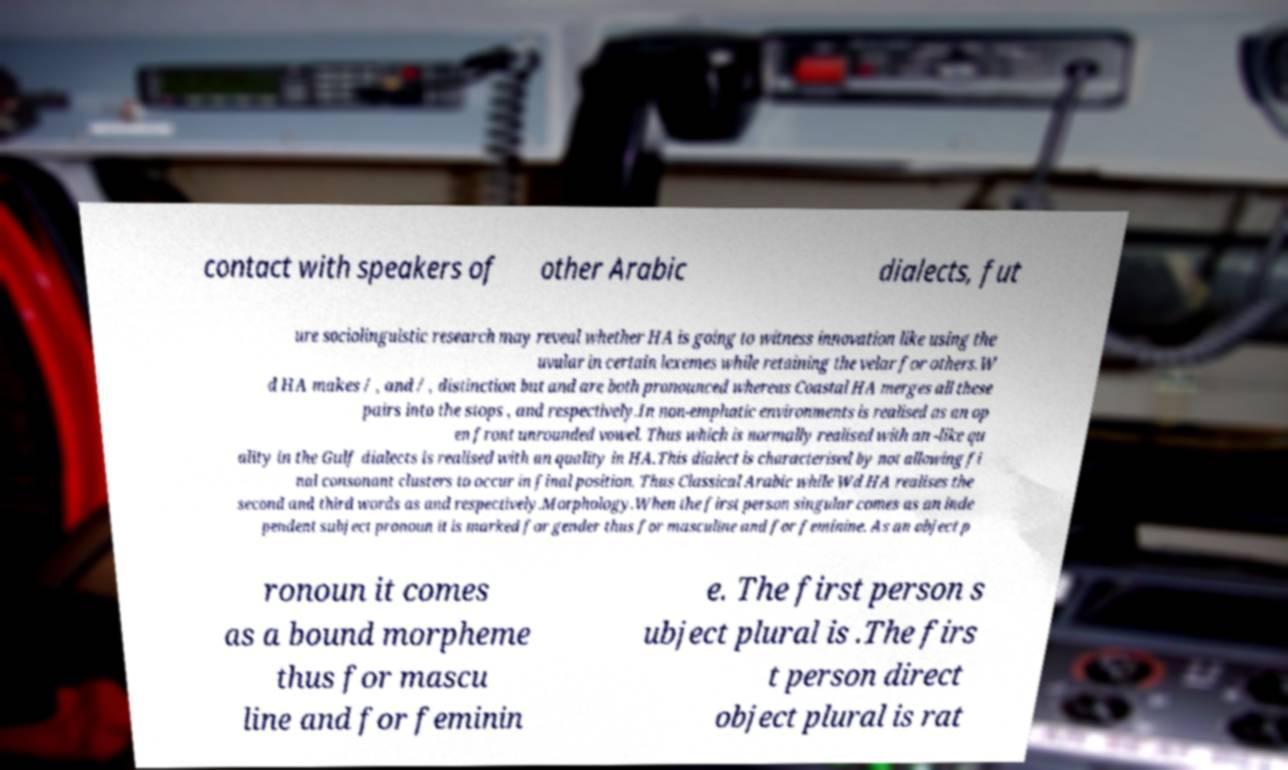There's text embedded in this image that I need extracted. Can you transcribe it verbatim? contact with speakers of other Arabic dialects, fut ure sociolinguistic research may reveal whether HA is going to witness innovation like using the uvular in certain lexemes while retaining the velar for others.W d HA makes / , and / , distinction but and are both pronounced whereas Coastal HA merges all these pairs into the stops , and respectively.In non-emphatic environments is realised as an op en front unrounded vowel. Thus which is normally realised with an -like qu ality in the Gulf dialects is realised with an quality in HA.This dialect is characterised by not allowing fi nal consonant clusters to occur in final position. Thus Classical Arabic while Wd HA realises the second and third words as and respectively.Morphology.When the first person singular comes as an inde pendent subject pronoun it is marked for gender thus for masculine and for feminine. As an object p ronoun it comes as a bound morpheme thus for mascu line and for feminin e. The first person s ubject plural is .The firs t person direct object plural is rat 